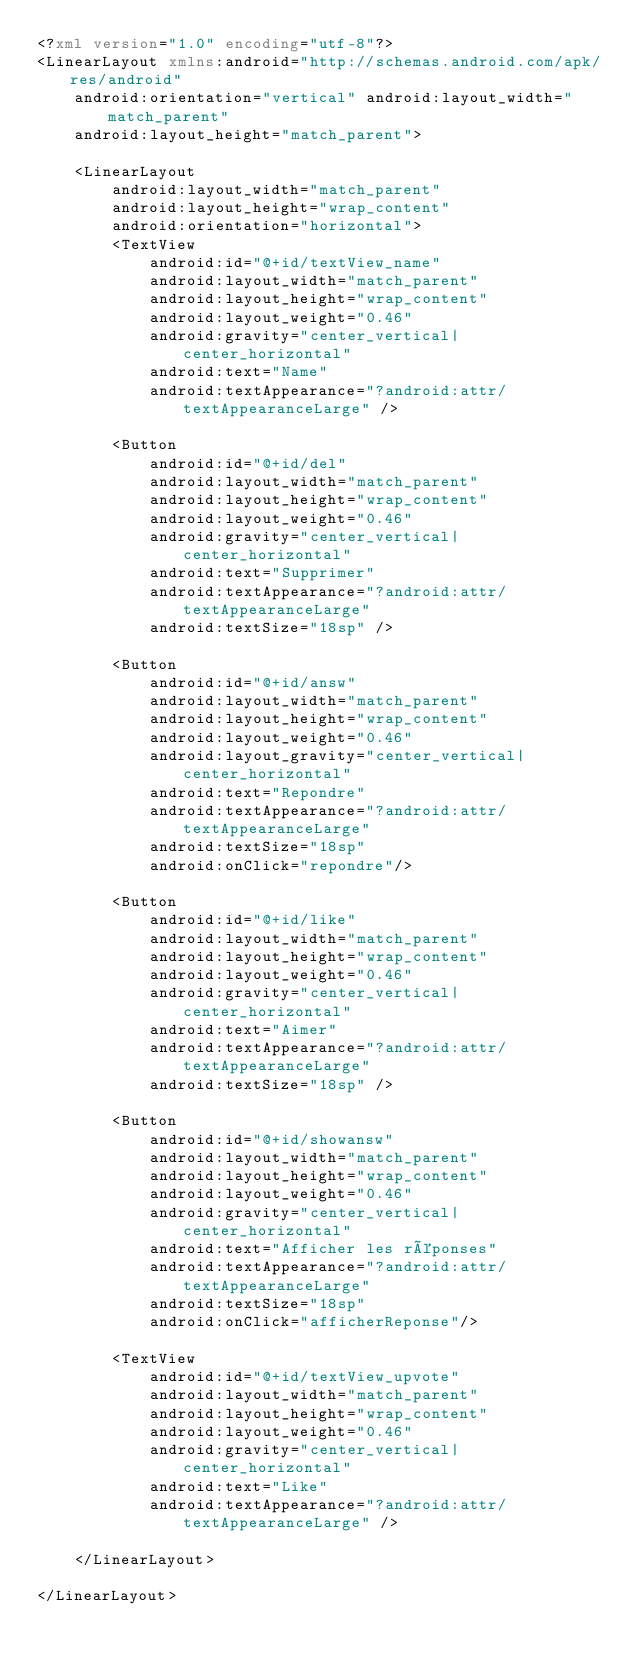<code> <loc_0><loc_0><loc_500><loc_500><_XML_><?xml version="1.0" encoding="utf-8"?>
<LinearLayout xmlns:android="http://schemas.android.com/apk/res/android"
    android:orientation="vertical" android:layout_width="match_parent"
    android:layout_height="match_parent">

    <LinearLayout
        android:layout_width="match_parent"
        android:layout_height="wrap_content"
        android:orientation="horizontal">
        <TextView
            android:id="@+id/textView_name"
            android:layout_width="match_parent"
            android:layout_height="wrap_content"
            android:layout_weight="0.46"
            android:gravity="center_vertical|center_horizontal"
            android:text="Name"
            android:textAppearance="?android:attr/textAppearanceLarge" />

        <Button
            android:id="@+id/del"
            android:layout_width="match_parent"
            android:layout_height="wrap_content"
            android:layout_weight="0.46"
            android:gravity="center_vertical|center_horizontal"
            android:text="Supprimer"
            android:textAppearance="?android:attr/textAppearanceLarge"
            android:textSize="18sp" />

        <Button
            android:id="@+id/answ"
            android:layout_width="match_parent"
            android:layout_height="wrap_content"
            android:layout_weight="0.46"
            android:layout_gravity="center_vertical|center_horizontal"
            android:text="Repondre"
            android:textAppearance="?android:attr/textAppearanceLarge"
            android:textSize="18sp"
            android:onClick="repondre"/>

        <Button
            android:id="@+id/like"
            android:layout_width="match_parent"
            android:layout_height="wrap_content"
            android:layout_weight="0.46"
            android:gravity="center_vertical|center_horizontal"
            android:text="Aimer"
            android:textAppearance="?android:attr/textAppearanceLarge"
            android:textSize="18sp" />

        <Button
            android:id="@+id/showansw"
            android:layout_width="match_parent"
            android:layout_height="wrap_content"
            android:layout_weight="0.46"
            android:gravity="center_vertical|center_horizontal"
            android:text="Afficher les réponses"
            android:textAppearance="?android:attr/textAppearanceLarge"
            android:textSize="18sp"
            android:onClick="afficherReponse"/>

        <TextView
            android:id="@+id/textView_upvote"
            android:layout_width="match_parent"
            android:layout_height="wrap_content"
            android:layout_weight="0.46"
            android:gravity="center_vertical|center_horizontal"
            android:text="Like"
            android:textAppearance="?android:attr/textAppearanceLarge" />

    </LinearLayout>

</LinearLayout></code> 